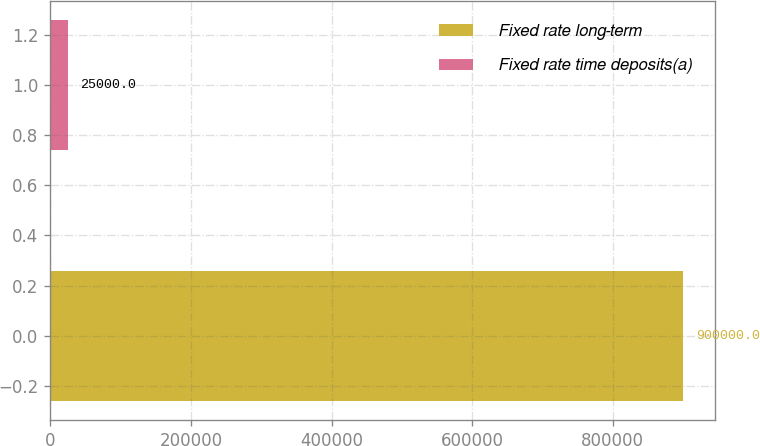Convert chart to OTSL. <chart><loc_0><loc_0><loc_500><loc_500><bar_chart><fcel>Fixed rate long-term<fcel>Fixed rate time deposits(a)<nl><fcel>900000<fcel>25000<nl></chart> 